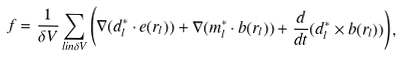<formula> <loc_0><loc_0><loc_500><loc_500>f = \frac { 1 } { \delta V } \sum _ { l i n \delta V } \left ( \nabla ( d _ { l } ^ { * } \cdot e ( r _ { l } ) ) + \nabla ( m _ { l } ^ { * } \cdot b ( r _ { l } ) ) + \frac { d } { d t } ( d _ { l } ^ { * } \times b ( r _ { l } ) ) \right ) ,</formula> 